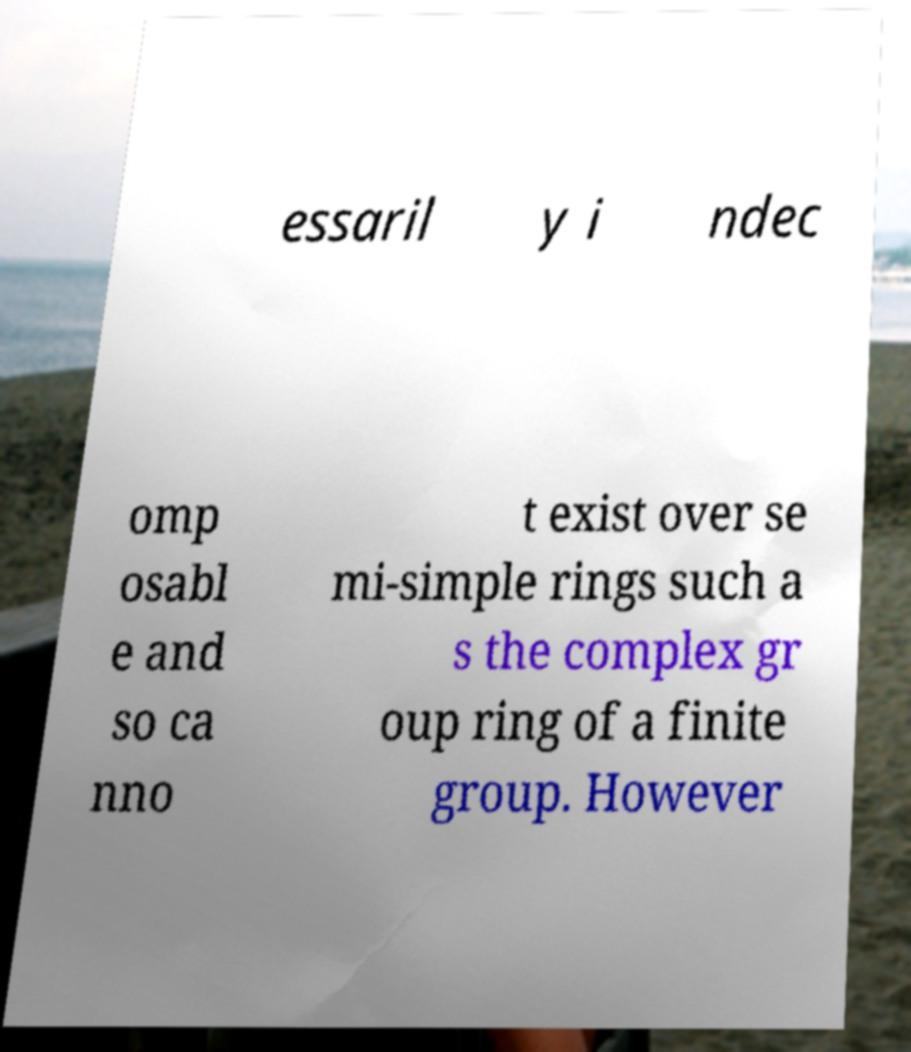Can you read and provide the text displayed in the image?This photo seems to have some interesting text. Can you extract and type it out for me? essaril y i ndec omp osabl e and so ca nno t exist over se mi-simple rings such a s the complex gr oup ring of a finite group. However 